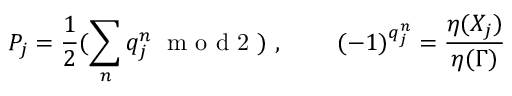<formula> <loc_0><loc_0><loc_500><loc_500>P _ { j } = \frac { 1 } { 2 } ( \sum _ { n } q _ { j } ^ { n } \, m o d 2 ) , \quad ( - 1 ) ^ { q _ { j } ^ { n } } = \frac { \eta ( X _ { j } ) } { \eta ( \Gamma ) }</formula> 